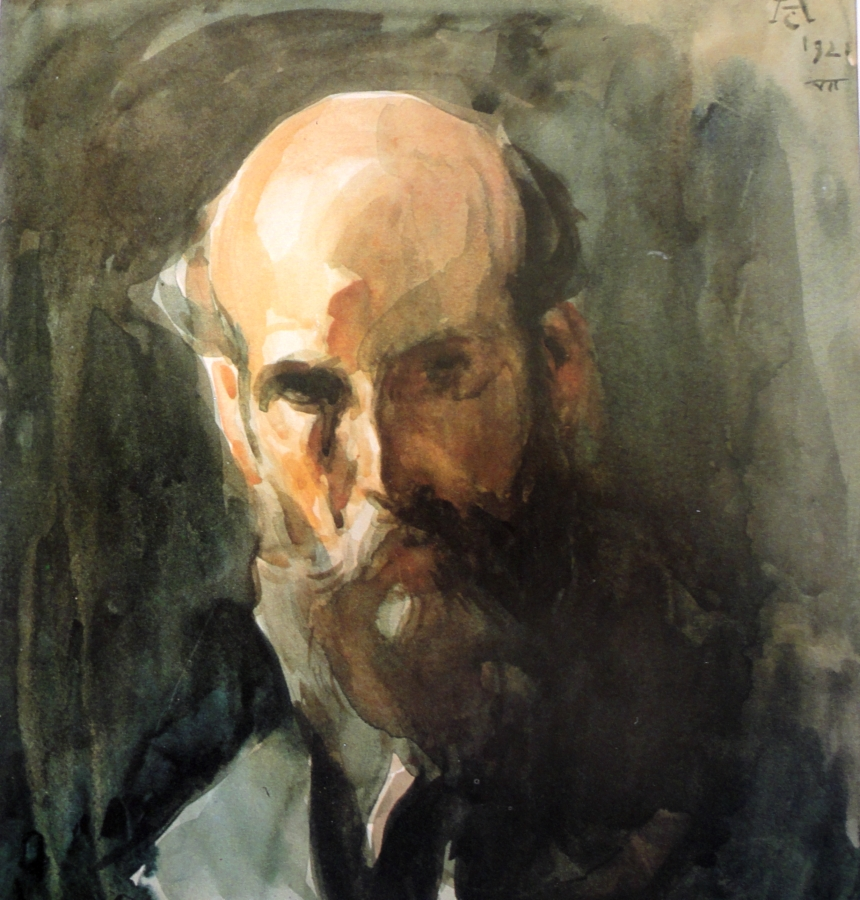What is this photo about? This is a watercolor painting portraying a bald man with a beard. The artist employs a loose, expressive technique that lends the portrait an abstract and mysterious character. The use of earthy tones such as browns and greens enhances the natural and subdued mood of the painting. The man's face, partially obscured by dynamic brushstrokes, emerges as the focal point, drawing the viewer's attention and adding an enigmatic aura to his identity. A dark, indistinct background further places emphasis on the subject’s face, accentuating the piece's overall intimate and contemplative feel. This artwork can be categorized under abstract portraiture. 